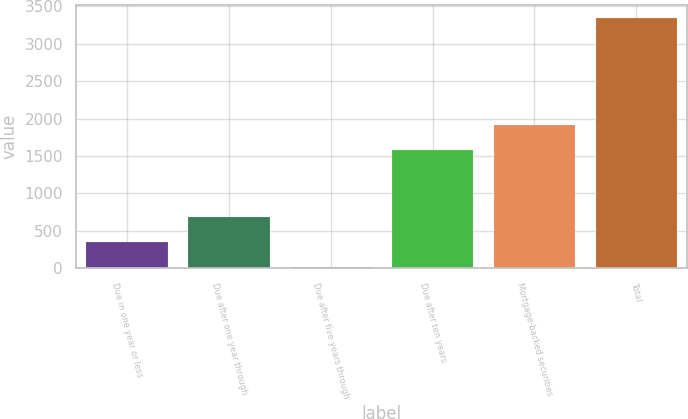Convert chart. <chart><loc_0><loc_0><loc_500><loc_500><bar_chart><fcel>Due in one year or less<fcel>Due after one year through<fcel>Due after five years through<fcel>Due after ten years<fcel>Mortgage-backed securities<fcel>Total<nl><fcel>350.7<fcel>683.4<fcel>18<fcel>1583<fcel>1915.7<fcel>3345<nl></chart> 